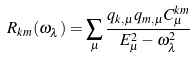<formula> <loc_0><loc_0><loc_500><loc_500>R _ { k m } ( \omega _ { \lambda } ) = \sum _ { \mu } \frac { q _ { k , \mu } q _ { m , \mu } C _ { \mu } ^ { k m } } { E _ { \mu } ^ { 2 } - \omega _ { \lambda } ^ { 2 } }</formula> 